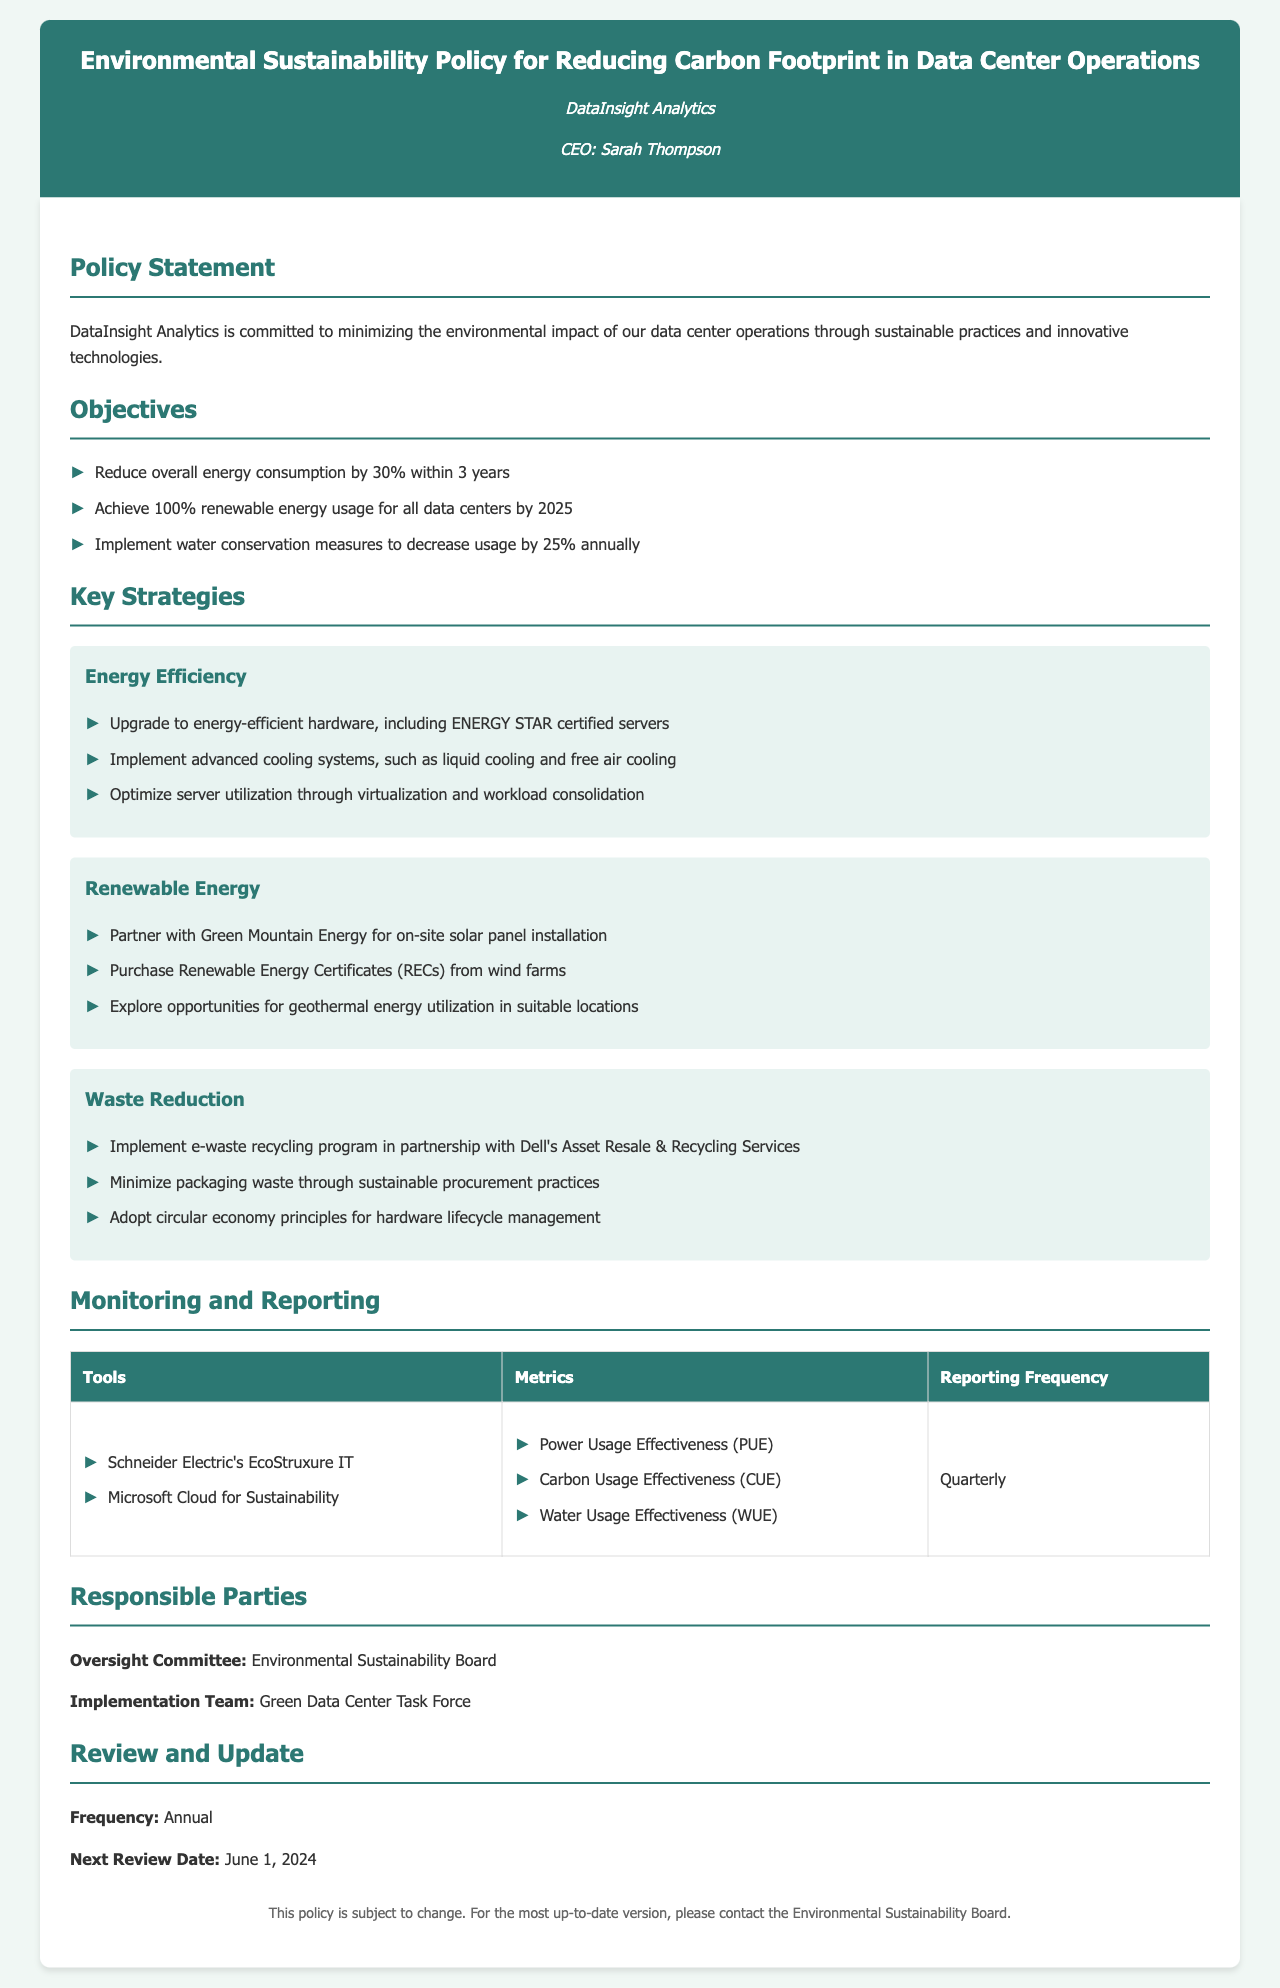What is the overall energy consumption reduction target? The target is specified in the objectives section of the document, which states that energy consumption will be reduced by 30%.
Answer: 30% What year is the target for achieving 100% renewable energy usage? The document mentions that the goal for 100% renewable energy usage will be achieved by 2025.
Answer: 2025 Who is the CEO of DataInsight Analytics? The CEO is listed in the header section of the document as Sarah Thompson.
Answer: Sarah Thompson What is the monitoring and reporting frequency for the sustainability metrics? The monitoring and reporting frequency for the metrics is detailed in the monitoring and reporting section, mentioned as quarterly.
Answer: Quarterly Which committee is responsible for oversight? The oversight committee is specified in the document as the Environmental Sustainability Board.
Answer: Environmental Sustainability Board What is one of the strategies to achieve energy efficiency? The document lists specific strategies under energy efficiency, such as upgrading to energy-efficient hardware like ENERGY STAR certified servers.
Answer: Upgrade to energy-efficient hardware How often will the policy be reviewed? The review frequency is mentioned in the review and update section and stated to be annual.
Answer: Annual What program is implemented for e-waste recycling? The document details the implementation of an e-waste recycling program in partnership with Dell's Asset Resale & Recycling Services.
Answer: Dell's Asset Resale & Recycling Services What is the next review date for the policy? The next review date is mentioned in the review and update section of the document as June 1, 2024.
Answer: June 1, 2024 